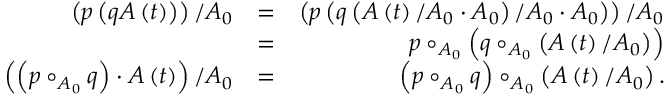Convert formula to latex. <formula><loc_0><loc_0><loc_500><loc_500>\begin{array} { r l r } { \left ( p \left ( q A \left ( t \right ) \right ) \right ) / A _ { 0 } } & { = } & { \left ( p \left ( q \left ( A \left ( t \right ) / A _ { 0 } \cdot A _ { 0 } \right ) / A _ { 0 } \cdot A _ { 0 } \right ) \right ) / A _ { 0 } } \\ & { = } & { p \circ _ { A _ { 0 } } \left ( q \circ _ { A _ { 0 } } \left ( A \left ( t \right ) / A _ { 0 } \right ) \right ) } \\ { \left ( \left ( p \circ _ { A _ { 0 } } q \right ) \cdot A \left ( t \right ) \right ) / A _ { 0 } } & { = } & { \left ( p \circ _ { A _ { 0 } } q \right ) \circ _ { A _ { 0 } } \left ( A \left ( t \right ) / A _ { 0 } \right ) . } \end{array}</formula> 